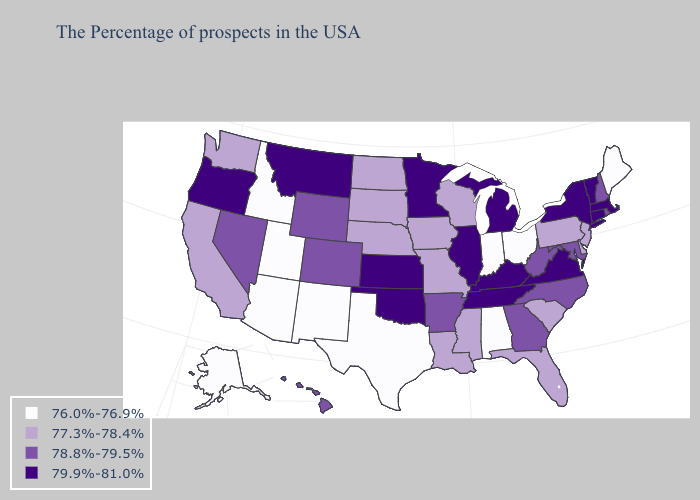What is the value of Kansas?
Write a very short answer. 79.9%-81.0%. Name the states that have a value in the range 79.9%-81.0%?
Be succinct. Massachusetts, Vermont, Connecticut, New York, Virginia, Michigan, Kentucky, Tennessee, Illinois, Minnesota, Kansas, Oklahoma, Montana, Oregon. Does Rhode Island have a lower value than New Jersey?
Quick response, please. No. What is the highest value in the USA?
Concise answer only. 79.9%-81.0%. What is the highest value in states that border New Mexico?
Give a very brief answer. 79.9%-81.0%. Does Tennessee have the lowest value in the USA?
Keep it brief. No. What is the value of Nebraska?
Short answer required. 77.3%-78.4%. Name the states that have a value in the range 79.9%-81.0%?
Concise answer only. Massachusetts, Vermont, Connecticut, New York, Virginia, Michigan, Kentucky, Tennessee, Illinois, Minnesota, Kansas, Oklahoma, Montana, Oregon. Name the states that have a value in the range 78.8%-79.5%?
Keep it brief. Rhode Island, New Hampshire, Maryland, North Carolina, West Virginia, Georgia, Arkansas, Wyoming, Colorado, Nevada, Hawaii. What is the value of South Dakota?
Quick response, please. 77.3%-78.4%. What is the highest value in states that border Utah?
Quick response, please. 78.8%-79.5%. Does New Hampshire have the highest value in the Northeast?
Be succinct. No. Does Maine have the lowest value in the Northeast?
Be succinct. Yes. Among the states that border Colorado , which have the highest value?
Quick response, please. Kansas, Oklahoma. What is the value of Alaska?
Concise answer only. 76.0%-76.9%. 